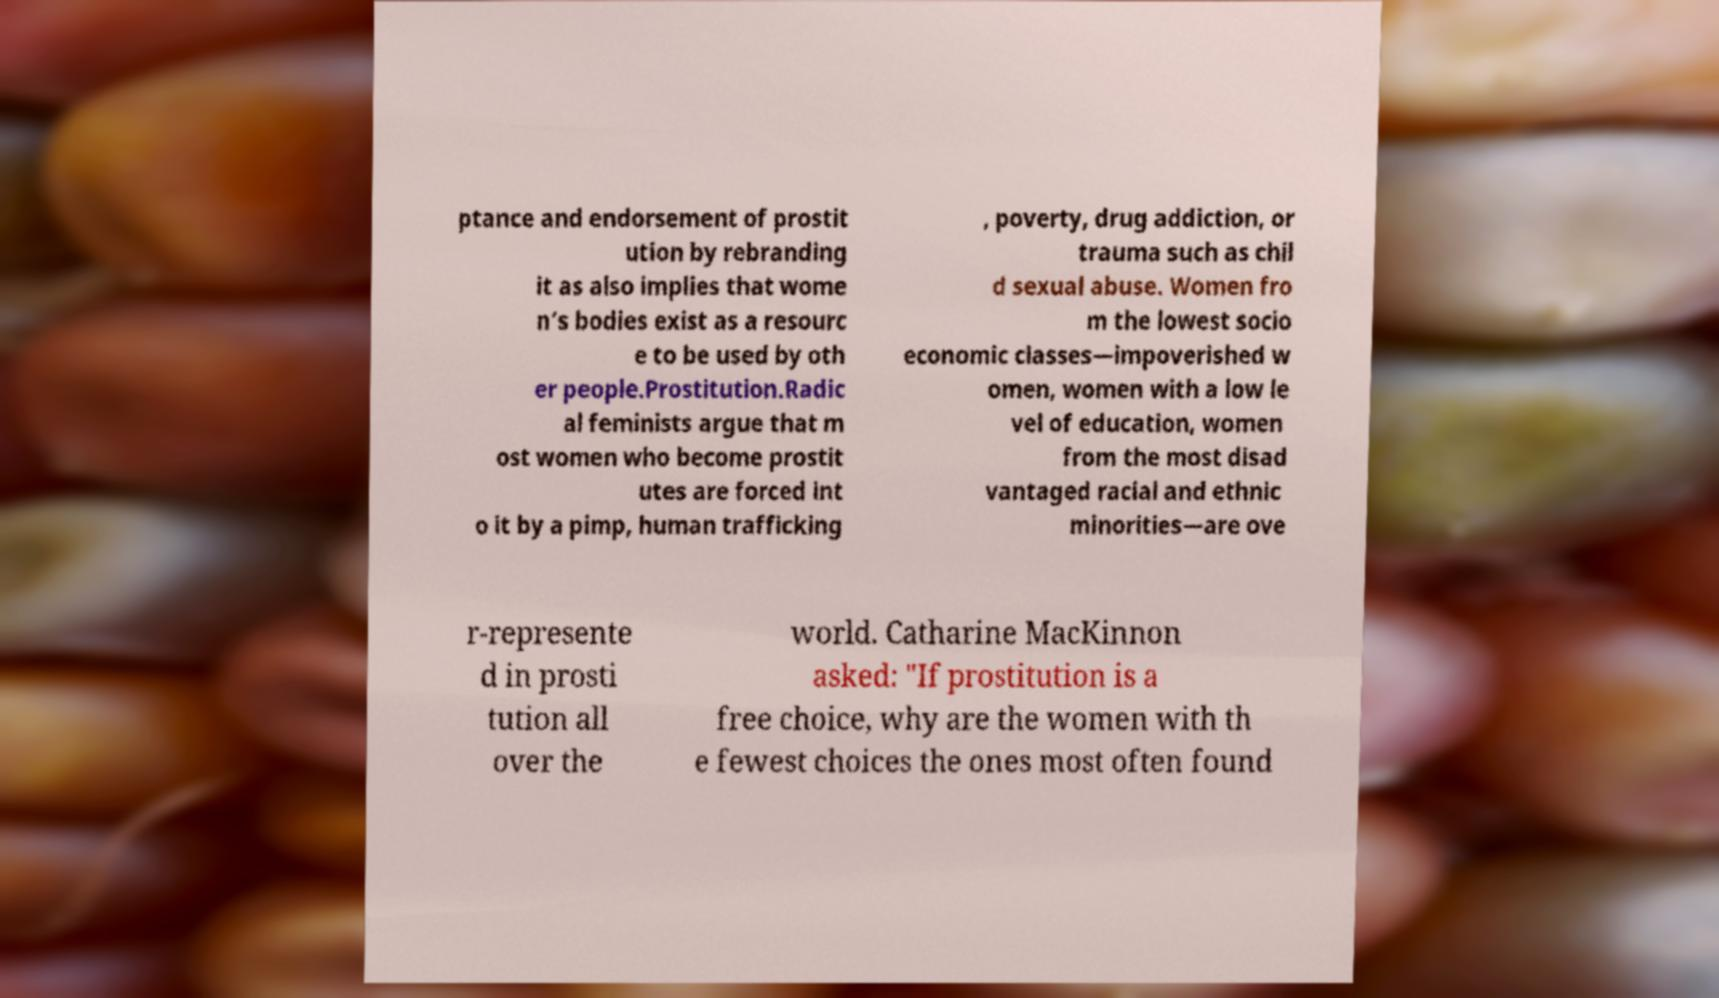Please identify and transcribe the text found in this image. ptance and endorsement of prostit ution by rebranding it as also implies that wome n’s bodies exist as a resourc e to be used by oth er people.Prostitution.Radic al feminists argue that m ost women who become prostit utes are forced int o it by a pimp, human trafficking , poverty, drug addiction, or trauma such as chil d sexual abuse. Women fro m the lowest socio economic classes—impoverished w omen, women with a low le vel of education, women from the most disad vantaged racial and ethnic minorities—are ove r-represente d in prosti tution all over the world. Catharine MacKinnon asked: "If prostitution is a free choice, why are the women with th e fewest choices the ones most often found 